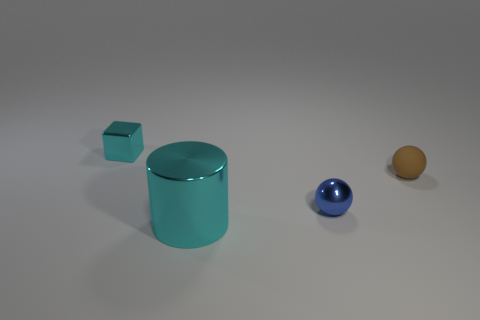Is the number of large cylinders in front of the metal block the same as the number of small brown rubber spheres that are to the left of the metallic cylinder?
Your answer should be very brief. No. Is the material of the thing to the right of the tiny blue object the same as the small thing that is to the left of the small blue metallic ball?
Your response must be concise. No. How many other objects are there of the same size as the cyan metallic cylinder?
Offer a terse response. 0. How many objects are metal cylinders or cyan things behind the big thing?
Make the answer very short. 2. Are there an equal number of blue things that are to the left of the large cyan shiny cylinder and small cyan things?
Your answer should be very brief. No. There is a blue thing that is the same material as the big cylinder; what shape is it?
Ensure brevity in your answer.  Sphere. Are there any cylinders of the same color as the rubber object?
Your answer should be compact. No. How many metallic things are either big cyan objects or tiny cyan cubes?
Ensure brevity in your answer.  2. There is a cyan object that is behind the big shiny object; how many cyan metal objects are in front of it?
Provide a short and direct response. 1. What number of cylinders have the same material as the small brown object?
Give a very brief answer. 0. 